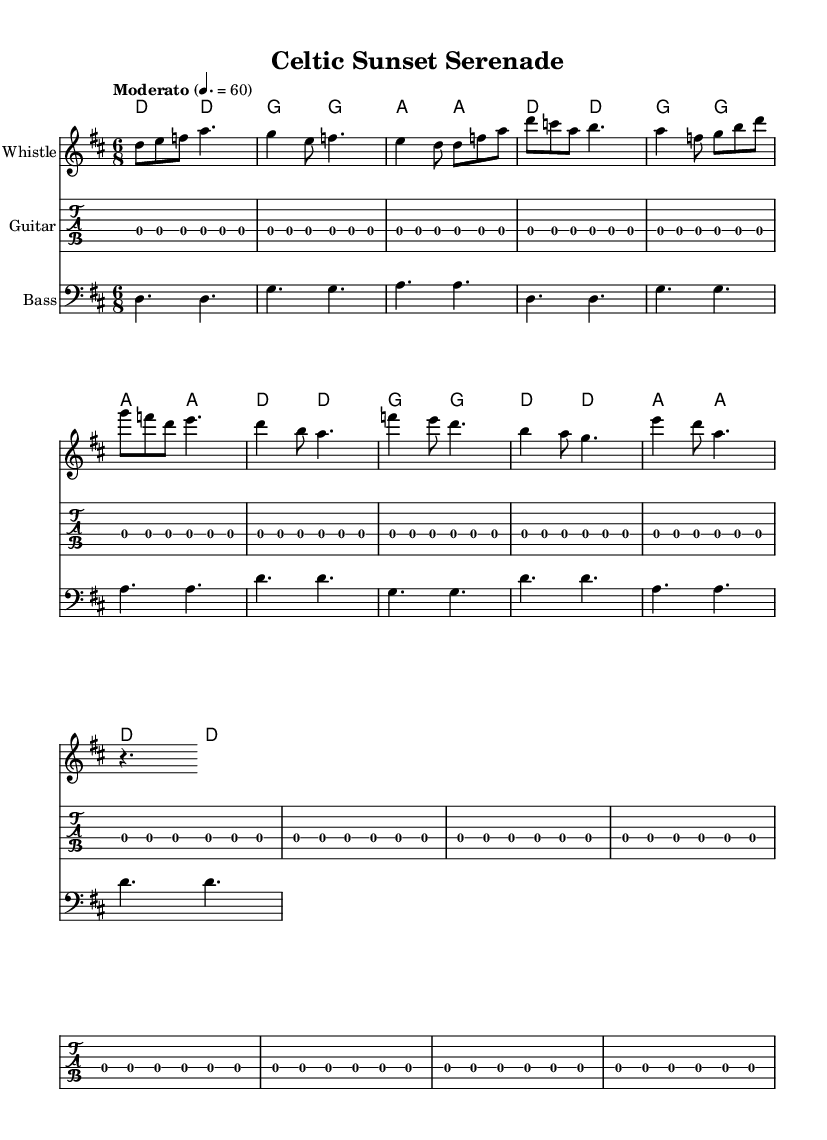What is the key signature of this music? The key signature indicated in the global section is D major, which has two sharps (F# and C#).
Answer: D major What is the time signature of this music? The time signature shown in the global section is 6/8, which indicates a compound duple meter typical for jig-style music, allowing for a lively feel.
Answer: 6/8 What is the tempo marking for this piece? The tempo marking specified is "Moderato" at a speed of 60 beats per minute, suggesting a moderate pace for the performance.
Answer: Moderato How many sections are present in the composition? The music consists of three main sections: Intro, Verse, and Chorus, each delivering distinct musical ideas while maintaining a cohesive overall structure.
Answer: Three What type of instrumentation is featured in this piece? The score includes a Whistle for melody, Guitar for harmonic support, and Bass to provide rhythmic foundation, typical of traditional Celtic music but with modern elements.
Answer: Whistle, Guitar, Bass Which musical mode is predominantly used in this piece? The melody predominantly uses the D major scale, characterized by a bright, uplifting sound that is often found in traditional Celtic folk music.
Answer: D major What is the rhythmic feel of this composition primarily based on? The piece is structured in a compound time signature (6/8), which typically lends a "lilt" to the music, often associated with traditional Celtic dances and folk tunes.
Answer: Compound 